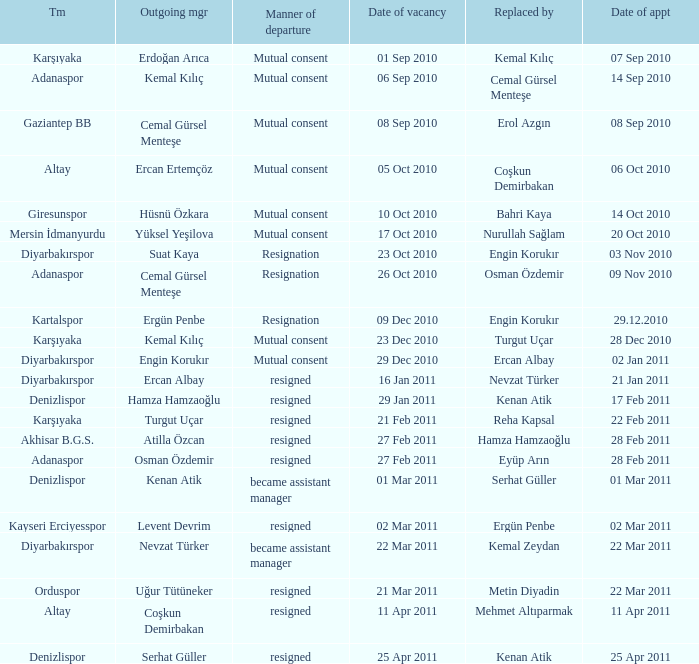Which team replaced their manager with Serhat Güller? Denizlispor. 